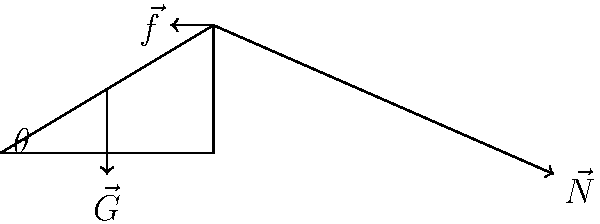In your latest critically acclaimed novel, you describe a scene where a character analyzes the forces acting on a book placed on an inclined plane. The diagram represents this scenario, with vectors showing gravity ($\vec{G}$), normal force ($\vec{N}$), and friction ($\vec{f}$). If the angle of inclination is $\theta$, express the magnitude of the normal force in terms of the object's mass $m$, gravitational acceleration $g$, and $\theta$. Let's approach this step-by-step, as if we were crafting a narrative of forces:

1) The gravitational force ($\vec{G}$) always acts vertically downward with magnitude $mg$.

2) The normal force ($\vec{N}$) is perpendicular to the inclined surface.

3) We need to find the component of gravity that's perpendicular to the inclined plane, as this will be equal and opposite to the normal force.

4) Imagine rotating the coordinate system so that the inclined plane becomes horizontal. The angle through which we rotate is $\theta$.

5) In this rotated system, the component of gravity perpendicular to the plane is $mg \cos\theta$.

6) Therefore, the magnitude of the normal force must be equal to this component to prevent the object from sinking into the plane.

Thus, we can express the magnitude of the normal force as:

$$|\vec{N}| = mg \cos\theta$$

This equation elegantly captures the relationship between the normal force, the object's mass, gravity, and the inclination angle, much like how a well-crafted sentence can encapsulate a complex idea in literature.
Answer: $mg \cos\theta$ 